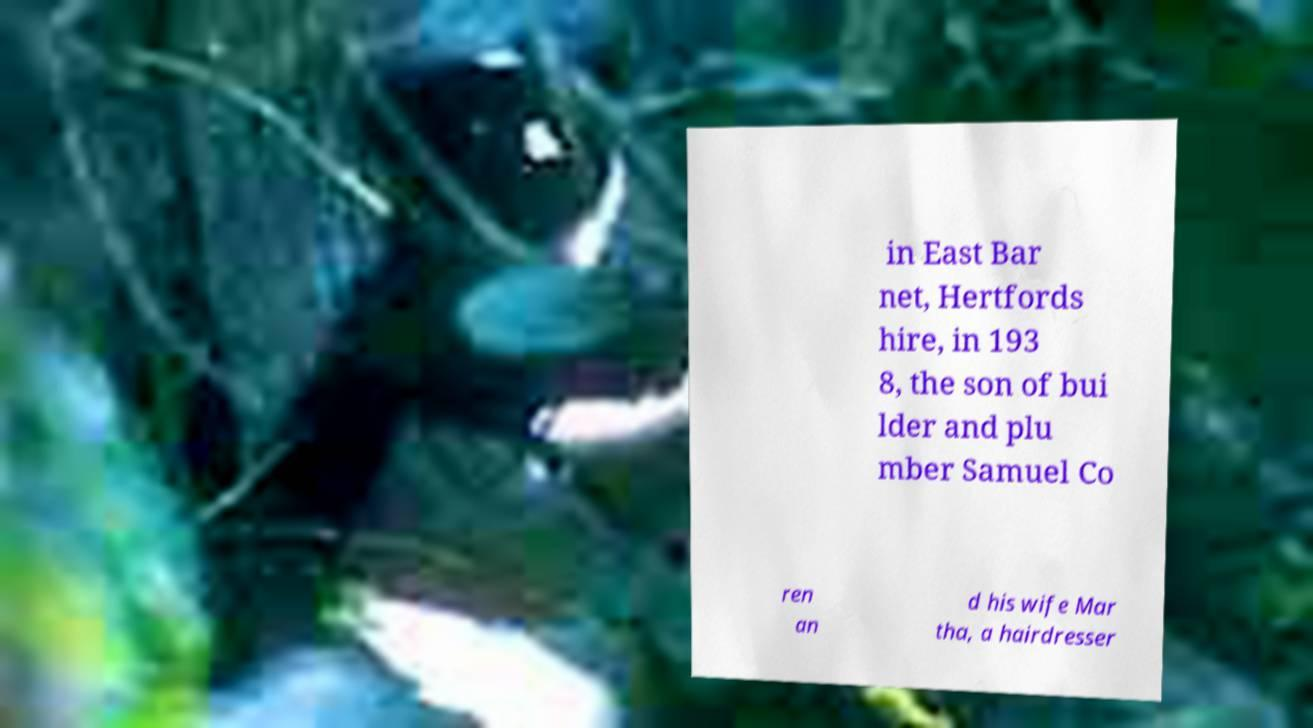Can you accurately transcribe the text from the provided image for me? in East Bar net, Hertfords hire, in 193 8, the son of bui lder and plu mber Samuel Co ren an d his wife Mar tha, a hairdresser 